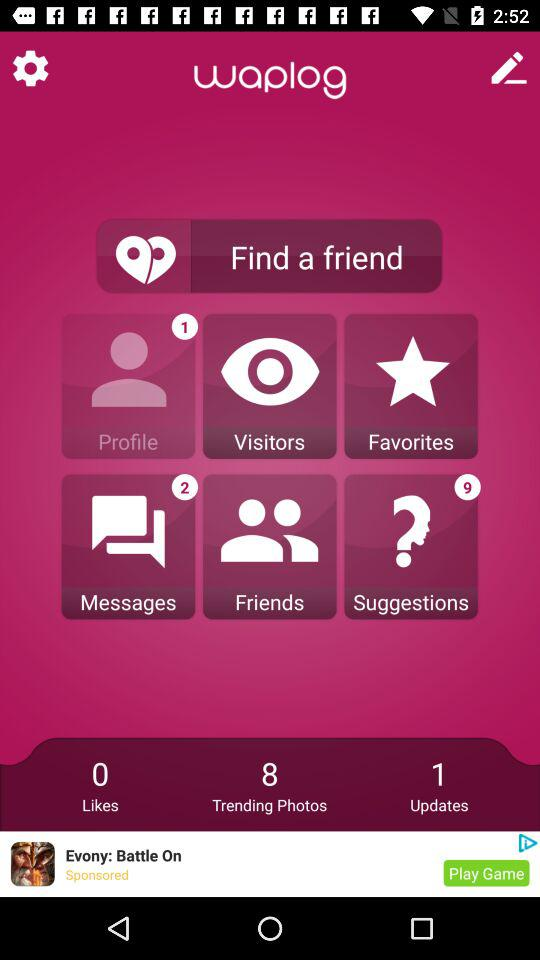How many trending photos are there? There are 8 trending photos. 